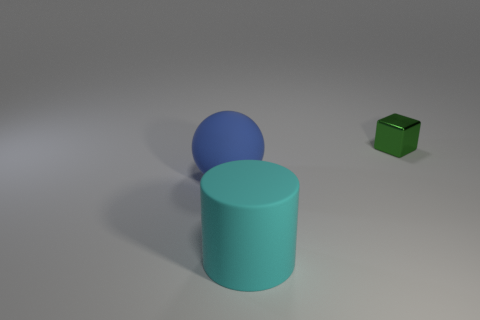Subtract all yellow cylinders. Subtract all purple balls. How many cylinders are left? 1 Subtract all blue spheres. How many blue blocks are left? 0 Add 1 small yellows. How many big cyans exist? 0 Subtract all red matte spheres. Subtract all small blocks. How many objects are left? 2 Add 2 cyan rubber cylinders. How many cyan rubber cylinders are left? 3 Add 3 tiny cyan rubber cylinders. How many tiny cyan rubber cylinders exist? 3 Add 2 big cyan rubber cylinders. How many objects exist? 5 Subtract 0 gray blocks. How many objects are left? 3 Subtract all cubes. How many objects are left? 2 Subtract 1 cylinders. How many cylinders are left? 0 